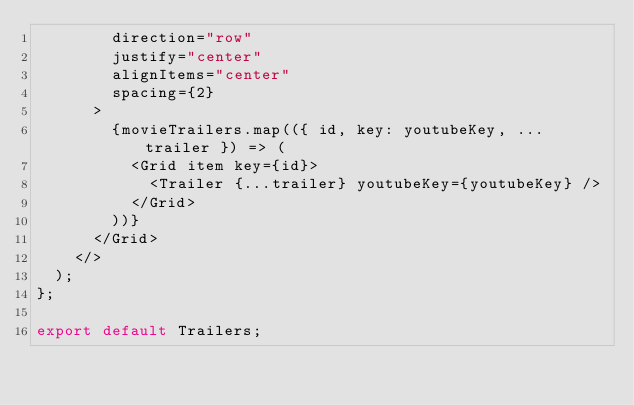<code> <loc_0><loc_0><loc_500><loc_500><_JavaScript_>        direction="row"
        justify="center"
        alignItems="center"
        spacing={2}
      >
        {movieTrailers.map(({ id, key: youtubeKey, ...trailer }) => (
          <Grid item key={id}>
            <Trailer {...trailer} youtubeKey={youtubeKey} />
          </Grid>
        ))}
      </Grid>
    </>
  );
};

export default Trailers;
</code> 